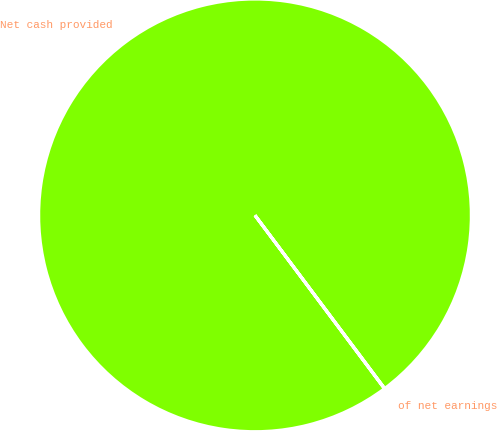<chart> <loc_0><loc_0><loc_500><loc_500><pie_chart><fcel>Net cash provided<fcel>of net earnings<nl><fcel>99.98%<fcel>0.02%<nl></chart> 